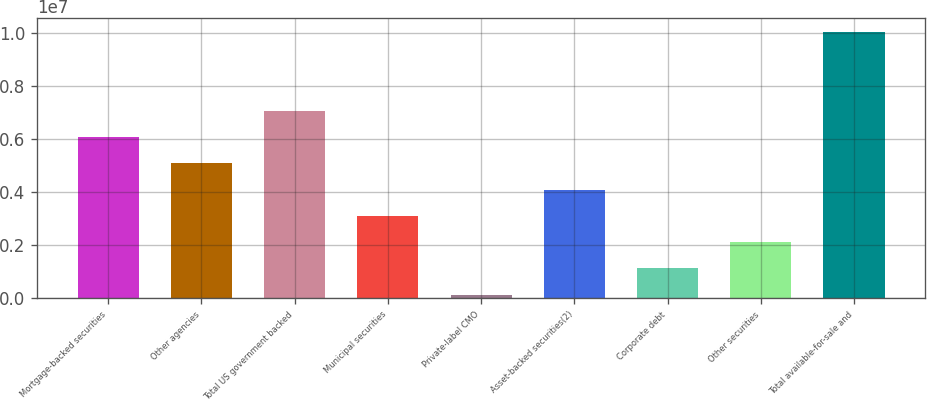<chart> <loc_0><loc_0><loc_500><loc_500><bar_chart><fcel>Mortgage-backed securities<fcel>Other agencies<fcel>Total US government backed<fcel>Municipal securities<fcel>Private-label CMO<fcel>Asset-backed securities(2)<fcel>Corporate debt<fcel>Other securities<fcel>Total available-for-sale and<nl><fcel>6.08536e+06<fcel>5.09355e+06<fcel>7.07717e+06<fcel>3.10994e+06<fcel>134509<fcel>4.10175e+06<fcel>1.12632e+06<fcel>2.11813e+06<fcel>1.00526e+07<nl></chart> 